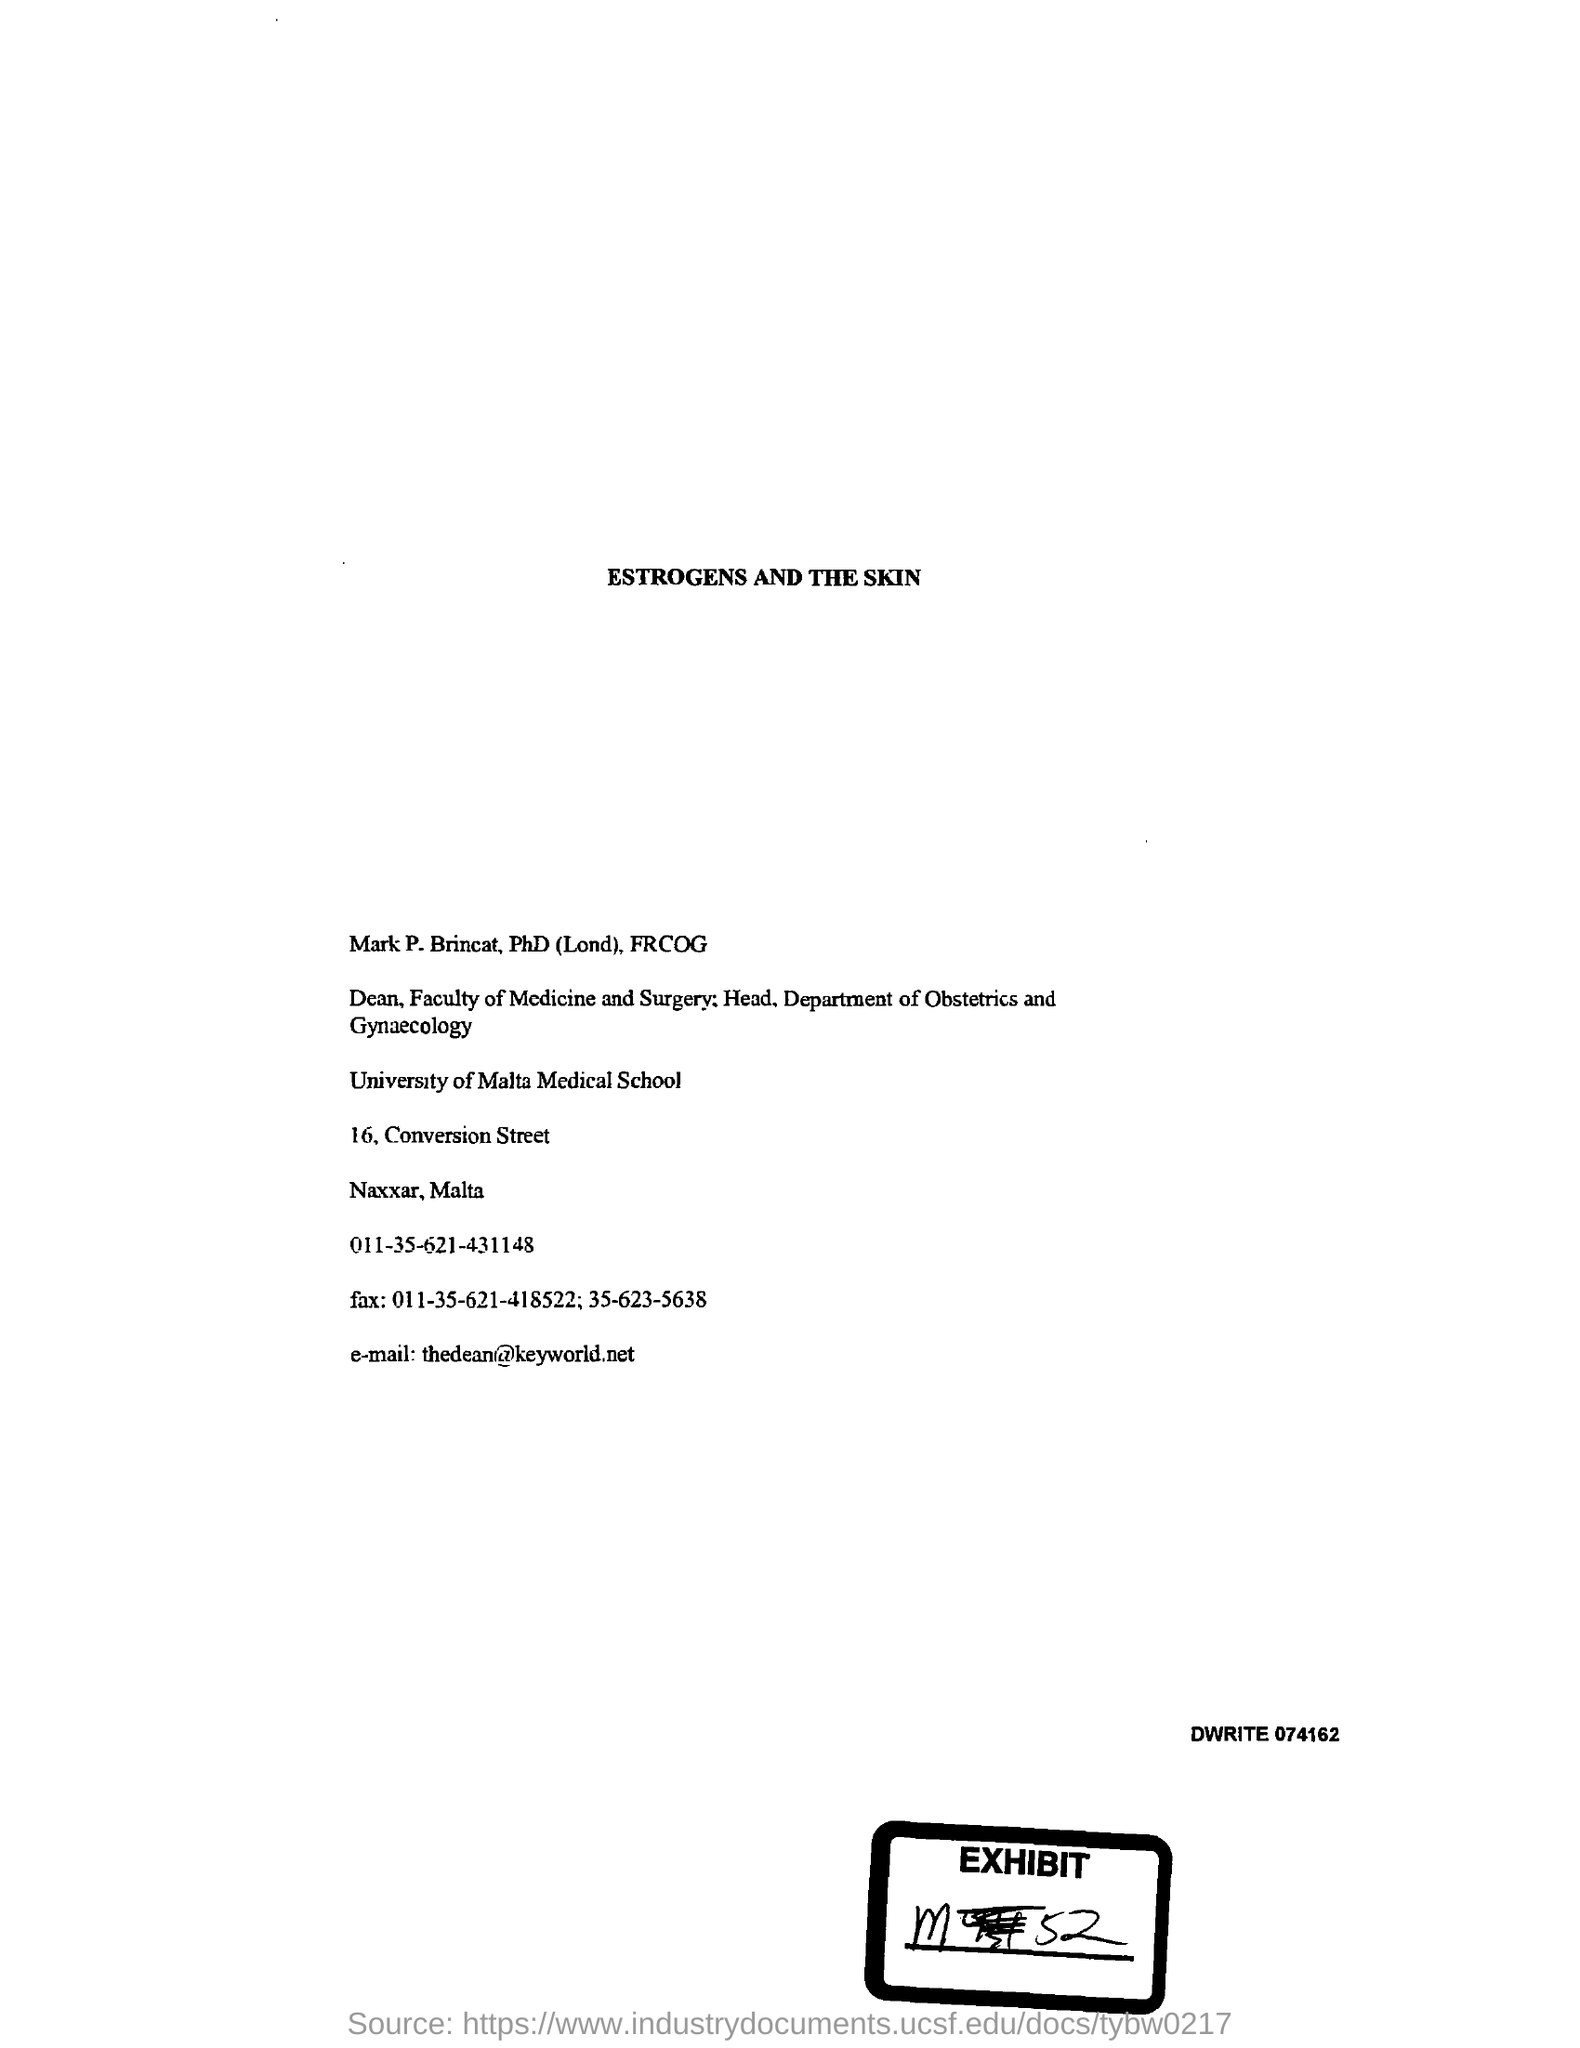Give some essential details in this illustration. What is the Exhibit number? It is m52. The email address is [what is the email id? thedean@keyworld.net]. 